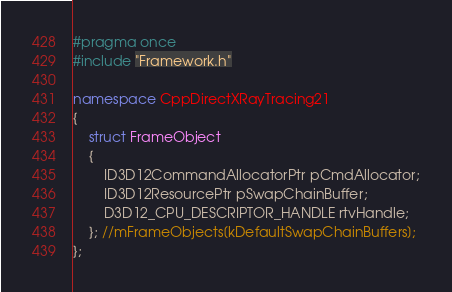Convert code to text. <code><loc_0><loc_0><loc_500><loc_500><_C++_>#pragma once
#include "Framework.h"

namespace CppDirectXRayTracing21
{
    struct FrameObject
    {
        ID3D12CommandAllocatorPtr pCmdAllocator;
        ID3D12ResourcePtr pSwapChainBuffer;
        D3D12_CPU_DESCRIPTOR_HANDLE rtvHandle;
    }; //mFrameObjects[kDefaultSwapChainBuffers];
};</code> 